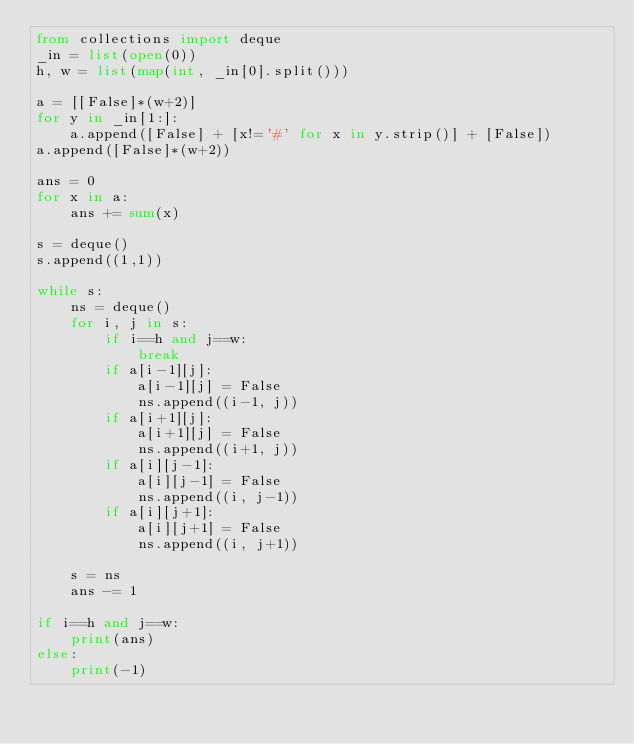<code> <loc_0><loc_0><loc_500><loc_500><_Python_>from collections import deque
_in = list(open(0))
h, w = list(map(int, _in[0].split()))

a = [[False]*(w+2)]
for y in _in[1:]:
    a.append([False] + [x!='#' for x in y.strip()] + [False])
a.append([False]*(w+2))

ans = 0
for x in a:
    ans += sum(x)

s = deque()
s.append((1,1))

while s:
    ns = deque()
    for i, j in s:
        if i==h and j==w:
            break
        if a[i-1][j]:
            a[i-1][j] = False
            ns.append((i-1, j))
        if a[i+1][j]:
            a[i+1][j] = False
            ns.append((i+1, j))
        if a[i][j-1]:
            a[i][j-1] = False
            ns.append((i, j-1))
        if a[i][j+1]:
            a[i][j+1] = False
            ns.append((i, j+1))
        
    s = ns
    ans -= 1

if i==h and j==w:
    print(ans)
else:
    print(-1)</code> 